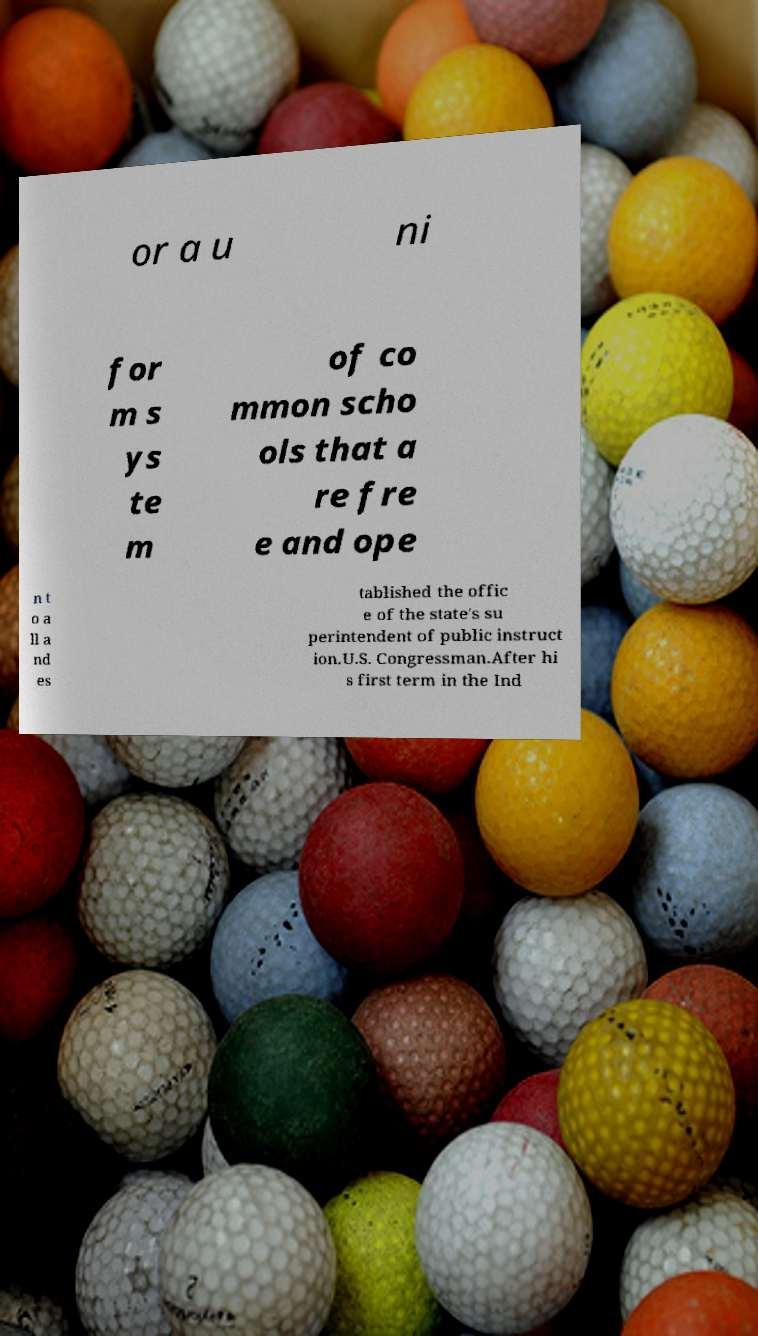What messages or text are displayed in this image? I need them in a readable, typed format. or a u ni for m s ys te m of co mmon scho ols that a re fre e and ope n t o a ll a nd es tablished the offic e of the state's su perintendent of public instruct ion.U.S. Congressman.After hi s first term in the Ind 